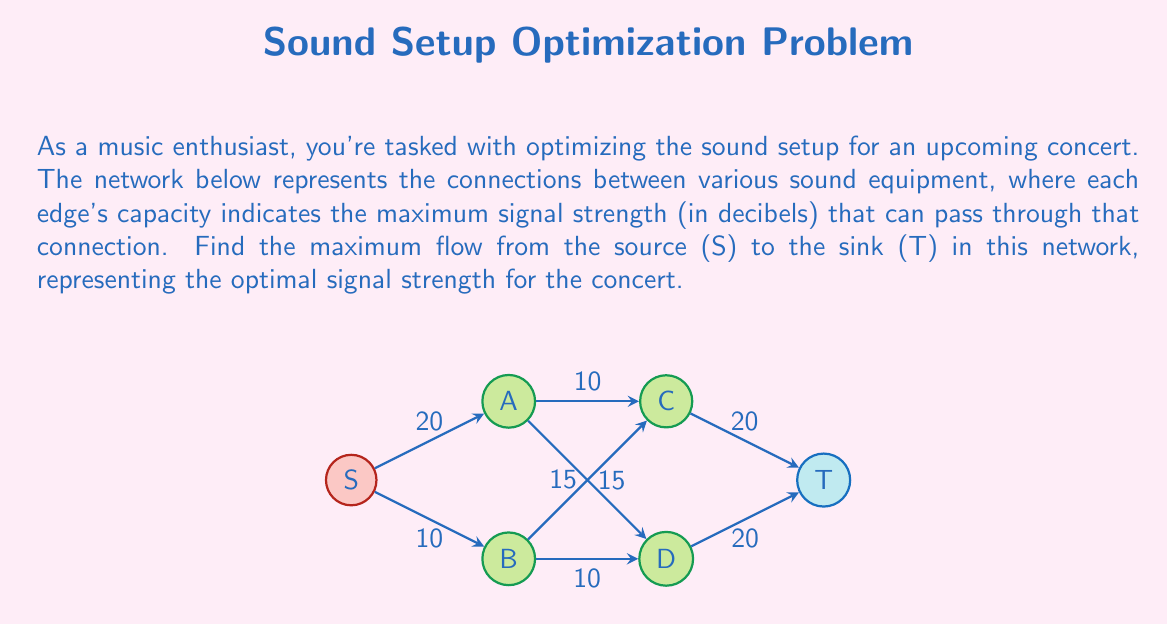Provide a solution to this math problem. To find the maximum flow in this network, we'll use the Ford-Fulkerson algorithm:

1) Initialize flow to 0 for all edges.

2) Find an augmenting path from S to T:
   Path 1: S → A → C → T (min capacity = 10)
   Update flow: 
   S → A: 10/20, A → C: 10/10, C → T: 10/20
   Total flow = 10

3) Find another augmenting path:
   Path 2: S → A → D → T (min capacity = 15)
   Update flow:
   S → A: 25/20 (exceeds capacity, so we use 20/20)
   A → D: 15/15, D → T: 15/20
   Total flow = 25

4) Find another augmenting path:
   Path 3: S → B → C → T (min capacity = 10)
   Update flow:
   S → B: 10/10, B → C: 10/15, C → T: 20/20
   Total flow = 35

5) Find another augmenting path:
   Path 4: S → B → D → T (min capacity = 5)
   Update flow:
   S → B: 10/10 (already at capacity)
   B → D: 5/10, D → T: 20/20
   Total flow = 40

6) No more augmenting paths exist, so the algorithm terminates.

The maximum flow is 40 decibels, achieved by:
- 20 dB through S → A → C/D → T
- 10 dB through S → B → C → T
- 10 dB through S → B → D → T
Answer: 40 decibels 